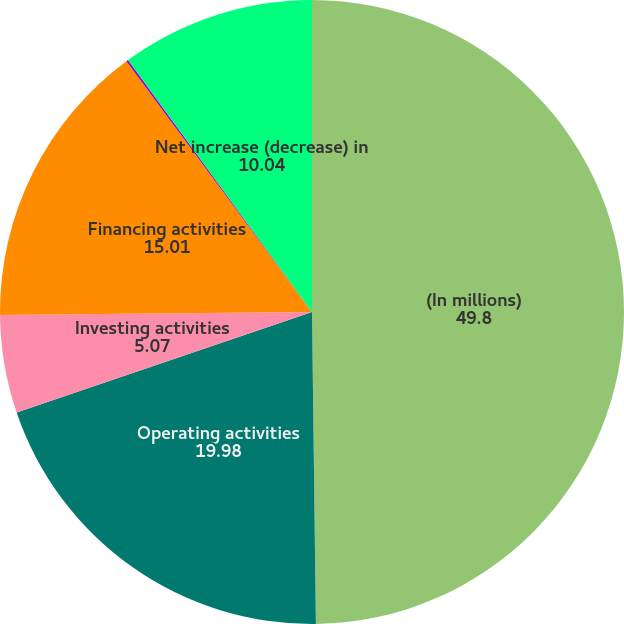Convert chart to OTSL. <chart><loc_0><loc_0><loc_500><loc_500><pie_chart><fcel>(In millions)<fcel>Operating activities<fcel>Investing activities<fcel>Financing activities<fcel>Effects of exchange rate<fcel>Net increase (decrease) in<nl><fcel>49.8%<fcel>19.98%<fcel>5.07%<fcel>15.01%<fcel>0.1%<fcel>10.04%<nl></chart> 